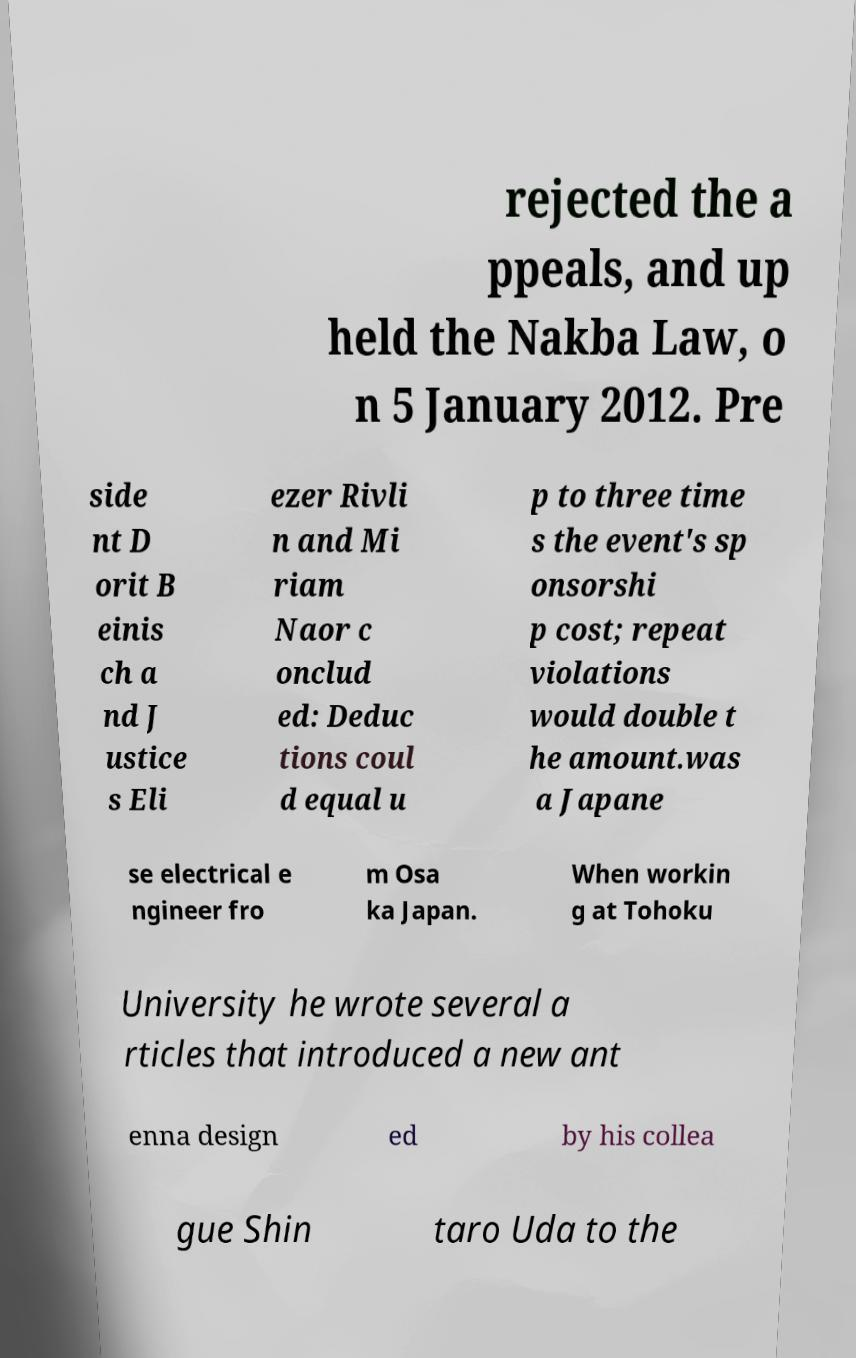Please identify and transcribe the text found in this image. rejected the a ppeals, and up held the Nakba Law, o n 5 January 2012. Pre side nt D orit B einis ch a nd J ustice s Eli ezer Rivli n and Mi riam Naor c onclud ed: Deduc tions coul d equal u p to three time s the event's sp onsorshi p cost; repeat violations would double t he amount.was a Japane se electrical e ngineer fro m Osa ka Japan. When workin g at Tohoku University he wrote several a rticles that introduced a new ant enna design ed by his collea gue Shin taro Uda to the 